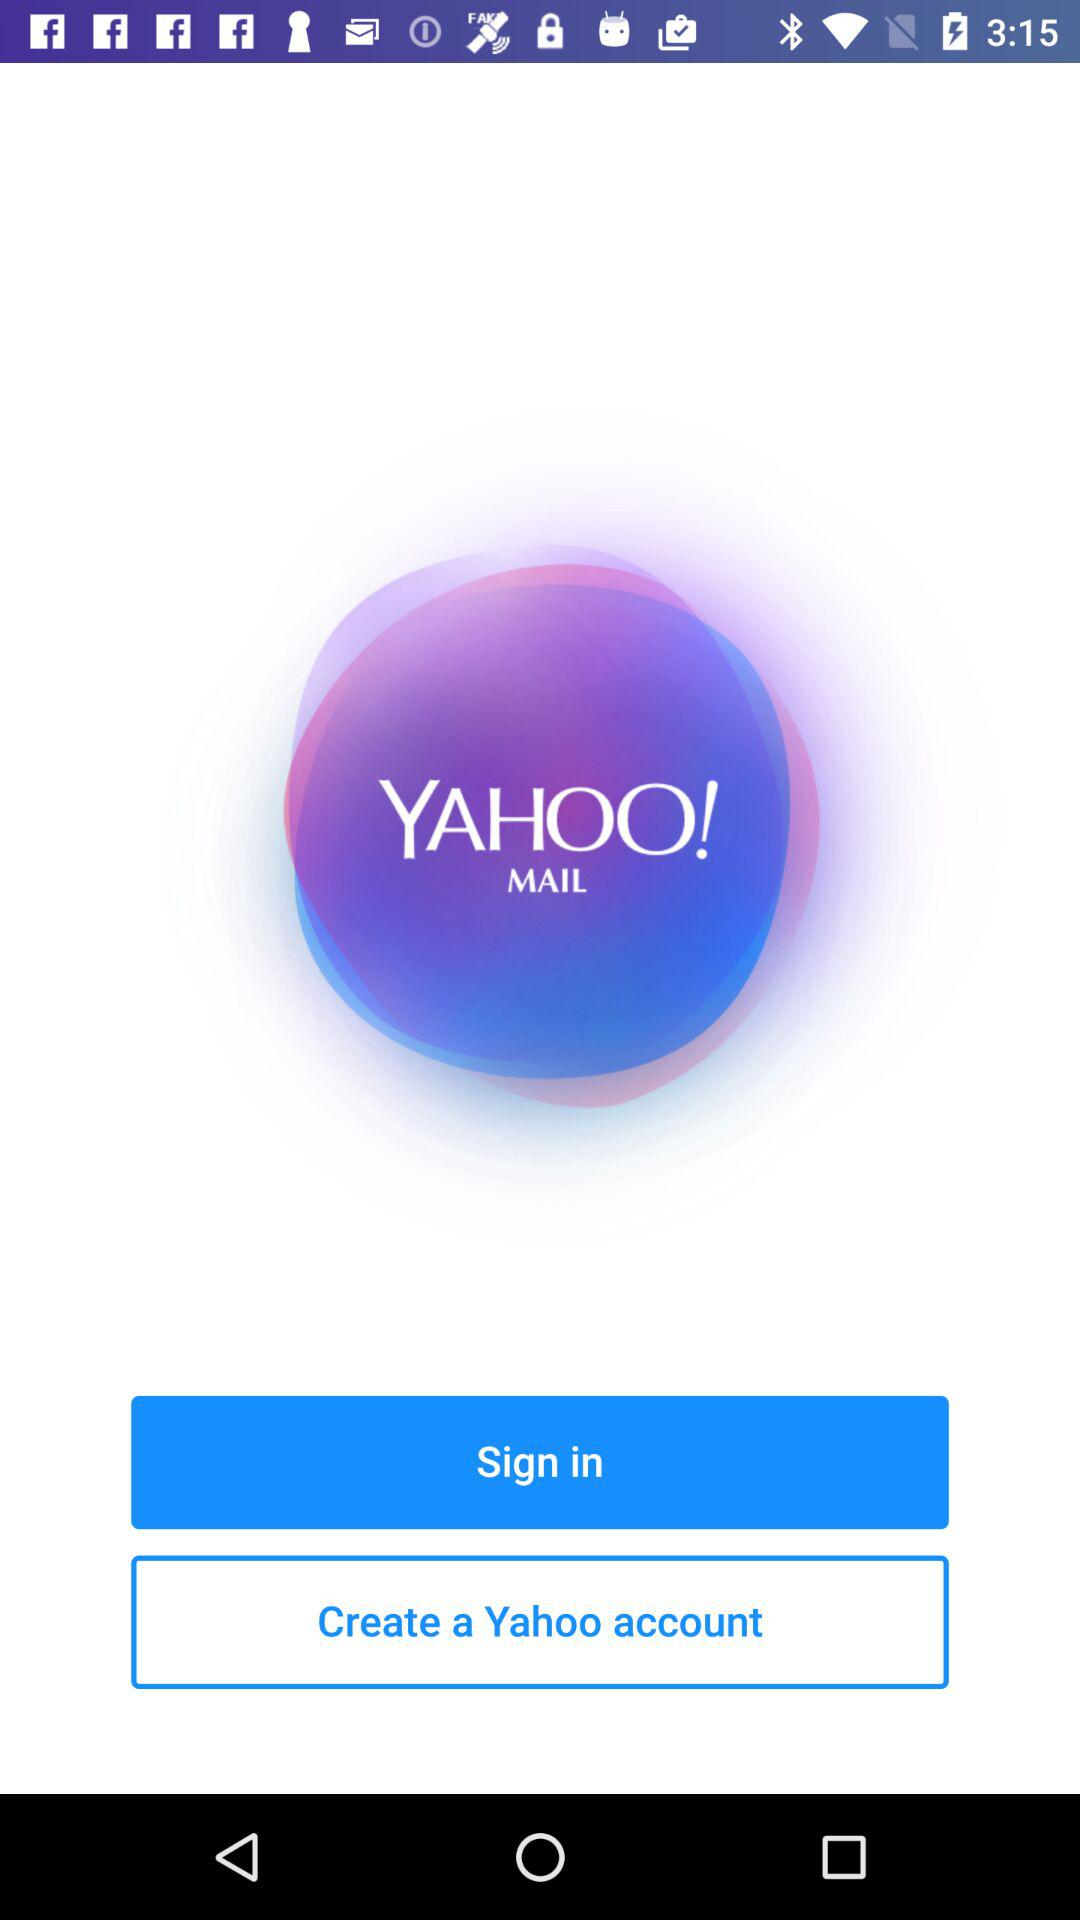What is the name of the "Yahoo" account?
When the provided information is insufficient, respond with <no answer>. <no answer> 